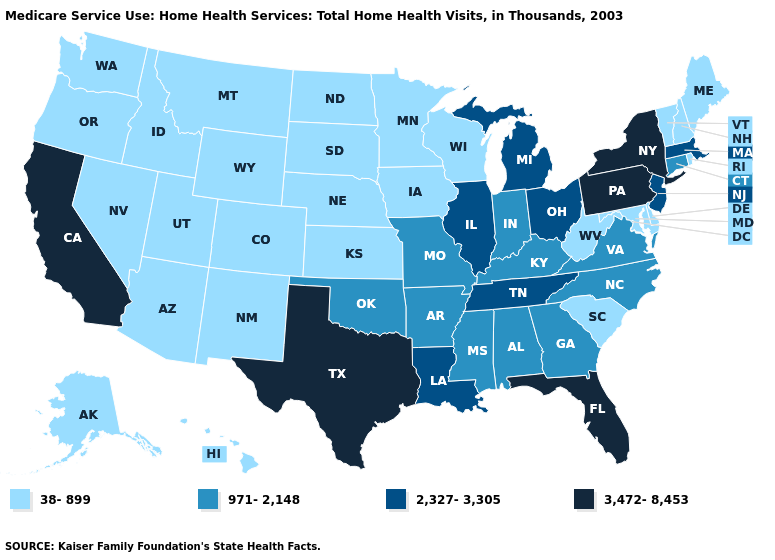What is the value of Nebraska?
Short answer required. 38-899. What is the value of Hawaii?
Short answer required. 38-899. Does Texas have a higher value than North Dakota?
Short answer required. Yes. Does the map have missing data?
Keep it brief. No. Does Georgia have a lower value than Colorado?
Answer briefly. No. Name the states that have a value in the range 38-899?
Short answer required. Alaska, Arizona, Colorado, Delaware, Hawaii, Idaho, Iowa, Kansas, Maine, Maryland, Minnesota, Montana, Nebraska, Nevada, New Hampshire, New Mexico, North Dakota, Oregon, Rhode Island, South Carolina, South Dakota, Utah, Vermont, Washington, West Virginia, Wisconsin, Wyoming. What is the lowest value in states that border Louisiana?
Concise answer only. 971-2,148. What is the value of California?
Keep it brief. 3,472-8,453. Is the legend a continuous bar?
Write a very short answer. No. What is the value of Hawaii?
Answer briefly. 38-899. Does Ohio have a higher value than Massachusetts?
Keep it brief. No. Name the states that have a value in the range 2,327-3,305?
Answer briefly. Illinois, Louisiana, Massachusetts, Michigan, New Jersey, Ohio, Tennessee. Does the first symbol in the legend represent the smallest category?
Answer briefly. Yes. Does California have the highest value in the West?
Answer briefly. Yes. Does Massachusetts have the lowest value in the USA?
Give a very brief answer. No. 